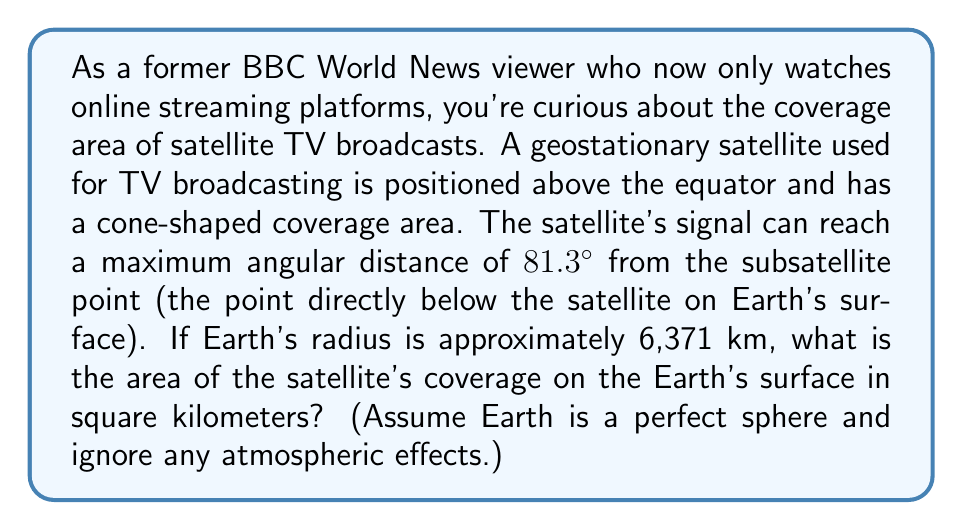Can you answer this question? To solve this problem, we'll use polar coordinates and spherical geometry. Let's break it down step-by-step:

1) First, we need to understand that the coverage area forms a spherical cap on Earth's surface.

2) The angle given (81.3°) is the maximum angular distance from the subsatellite point to the edge of the coverage area. This angle is also known as the Earth central angle.

3) To find the area of a spherical cap, we use the formula:

   $$A = 2\pi R^2(1 - \cos\theta)$$

   Where:
   $A$ is the area of the spherical cap
   $R$ is the radius of the Earth
   $\theta$ is the Earth central angle in radians

4) We're given $R = 6,371$ km and $\theta = 81.3°$. We need to convert the angle to radians:

   $$\theta = 81.3° \times \frac{\pi}{180°} = 1.4189 \text{ radians}$$

5) Now we can plug these values into our formula:

   $$A = 2\pi (6,371 \text{ km})^2(1 - \cos(1.4189))$$

6) Let's evaluate this step-by-step:
   
   $$A = 2\pi \times 40,589,641 \text{ km}^2 \times (1 - 0.1305)$$
   $$A = 255,413,506 \text{ km}^2 \times 0.8695$$
   $$A = 222,082,043 \text{ km}^2$$

7) Rounding to the nearest thousand square kilometers:

   $$A \approx 222,082,000 \text{ km}^2$$
Answer: The area of the satellite's coverage on the Earth's surface is approximately 222,082,000 km². 